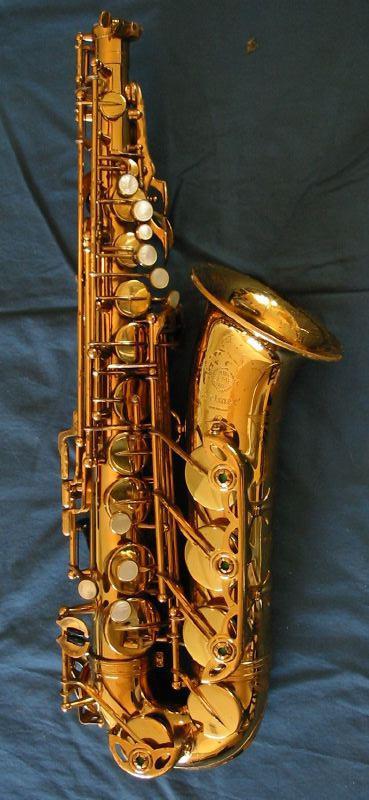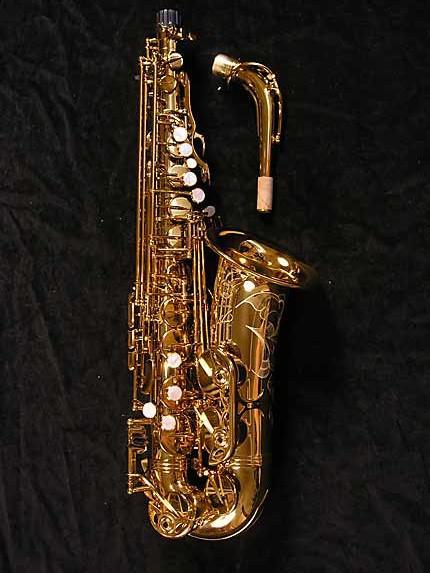The first image is the image on the left, the second image is the image on the right. For the images displayed, is the sentence "In one image, a saxophone is shown in an upright position with the mouthpiece removed and placed beside it." factually correct? Answer yes or no. Yes. The first image is the image on the left, the second image is the image on the right. For the images displayed, is the sentence "One image shows a saxophone displayed on black with its mouthpiece separated." factually correct? Answer yes or no. Yes. 